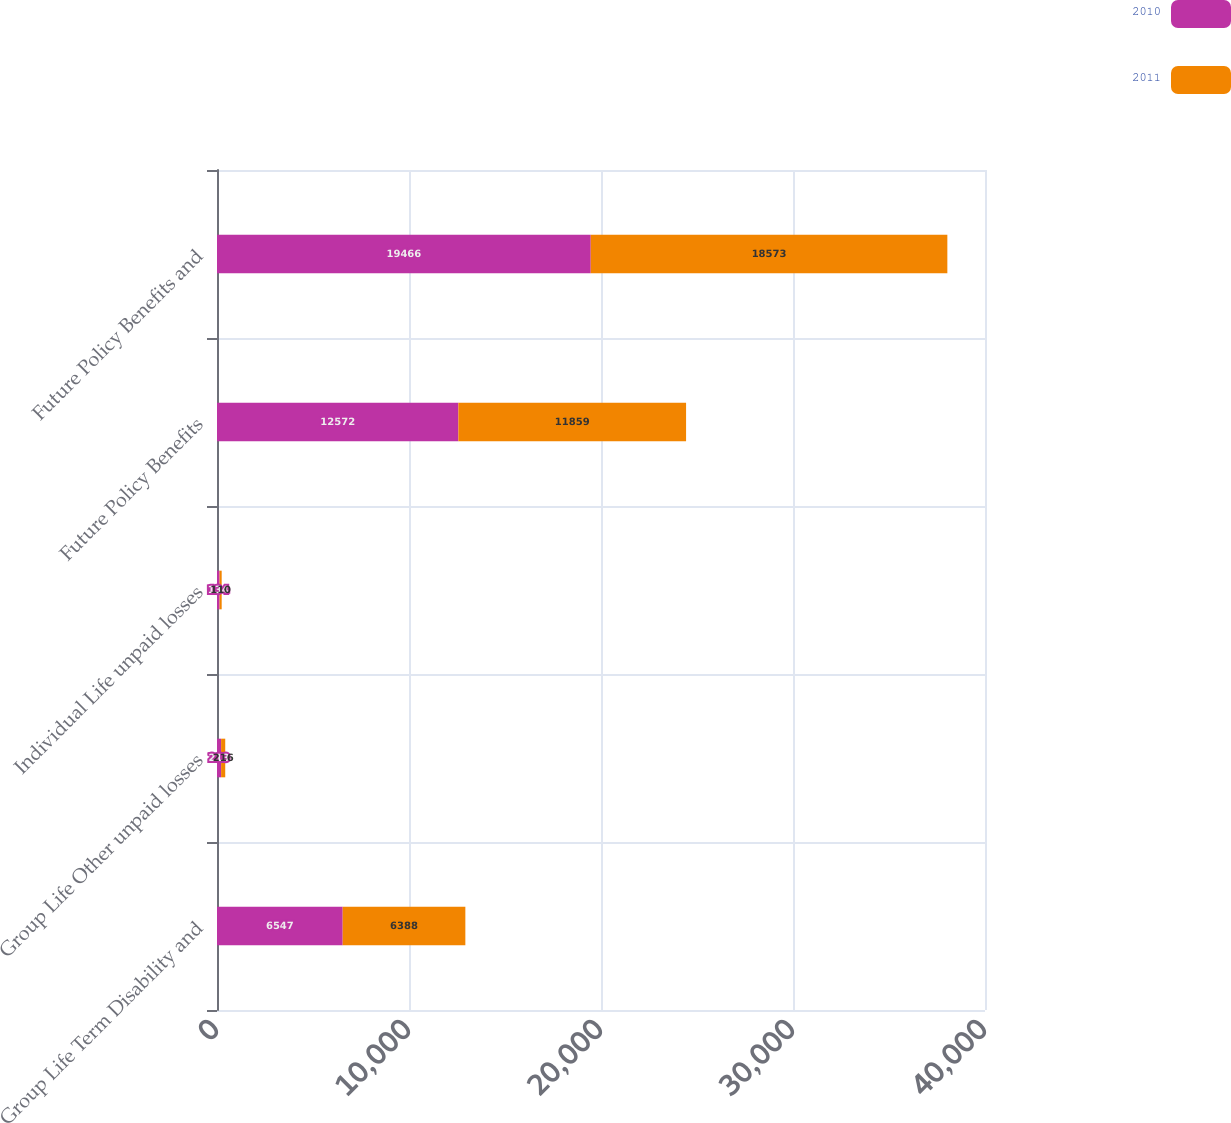<chart> <loc_0><loc_0><loc_500><loc_500><stacked_bar_chart><ecel><fcel>Group Life Term Disability and<fcel>Group Life Other unpaid losses<fcel>Individual Life unpaid losses<fcel>Future Policy Benefits<fcel>Future Policy Benefits and<nl><fcel>2010<fcel>6547<fcel>213<fcel>134<fcel>12572<fcel>19466<nl><fcel>2011<fcel>6388<fcel>216<fcel>110<fcel>11859<fcel>18573<nl></chart> 